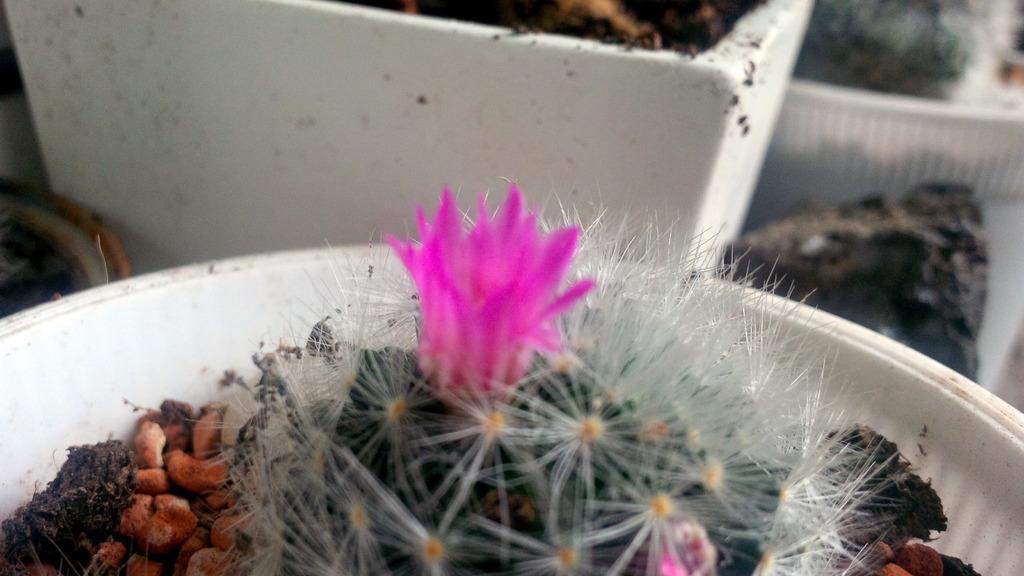Describe this image in one or two sentences. In this picture we can see a plant, flowers, stones and a plant pot in the front, there is soil in the background, we can see a blurry background. 